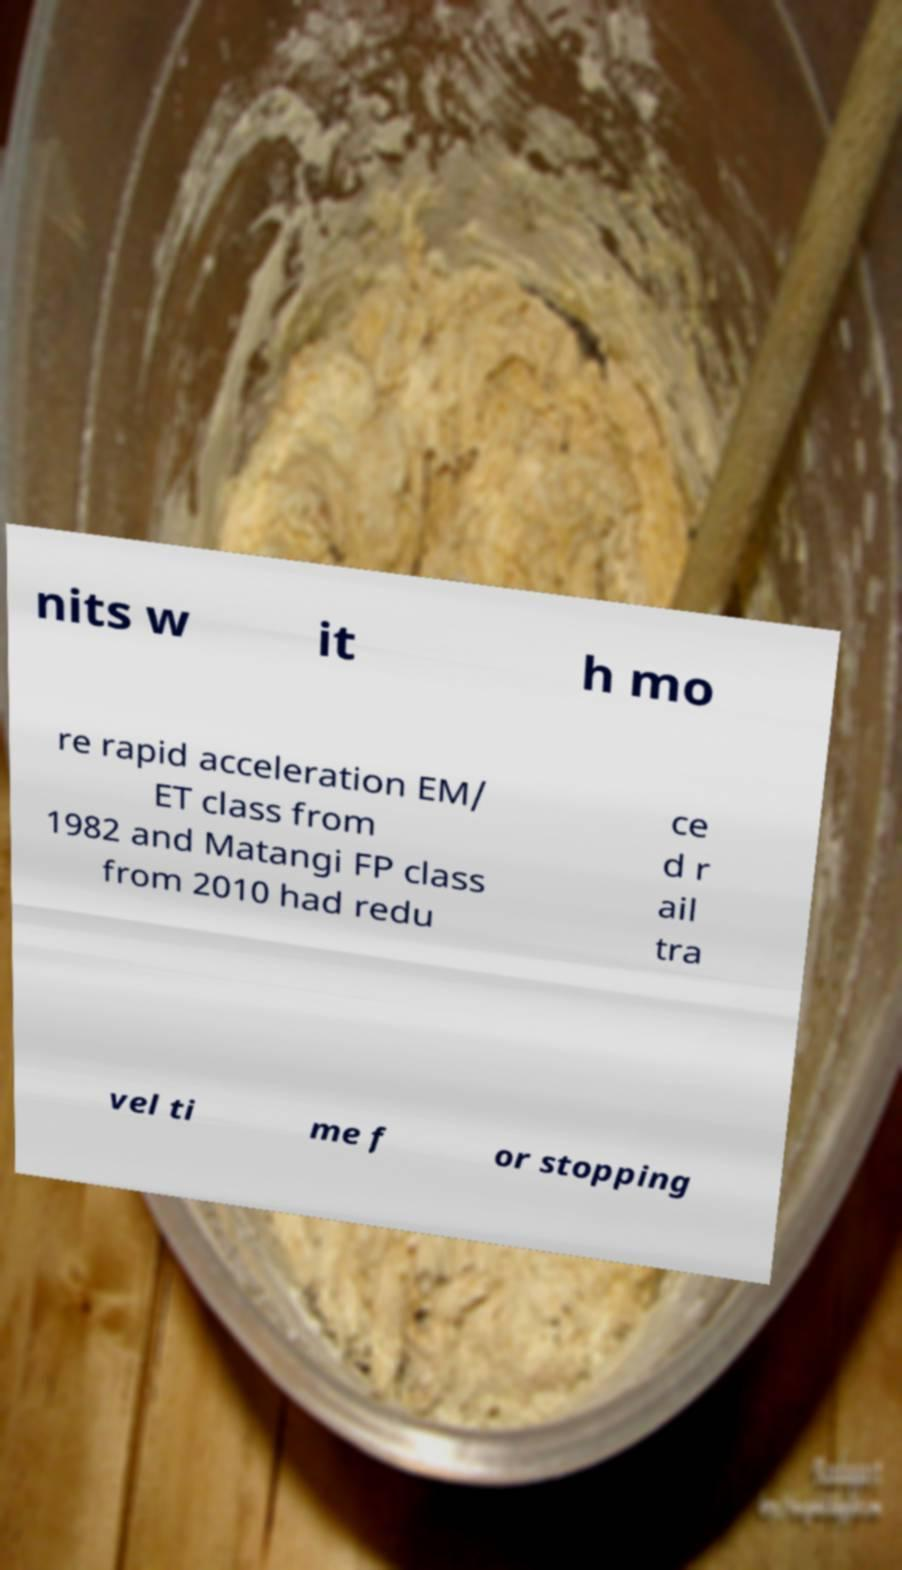Can you accurately transcribe the text from the provided image for me? nits w it h mo re rapid acceleration EM/ ET class from 1982 and Matangi FP class from 2010 had redu ce d r ail tra vel ti me f or stopping 